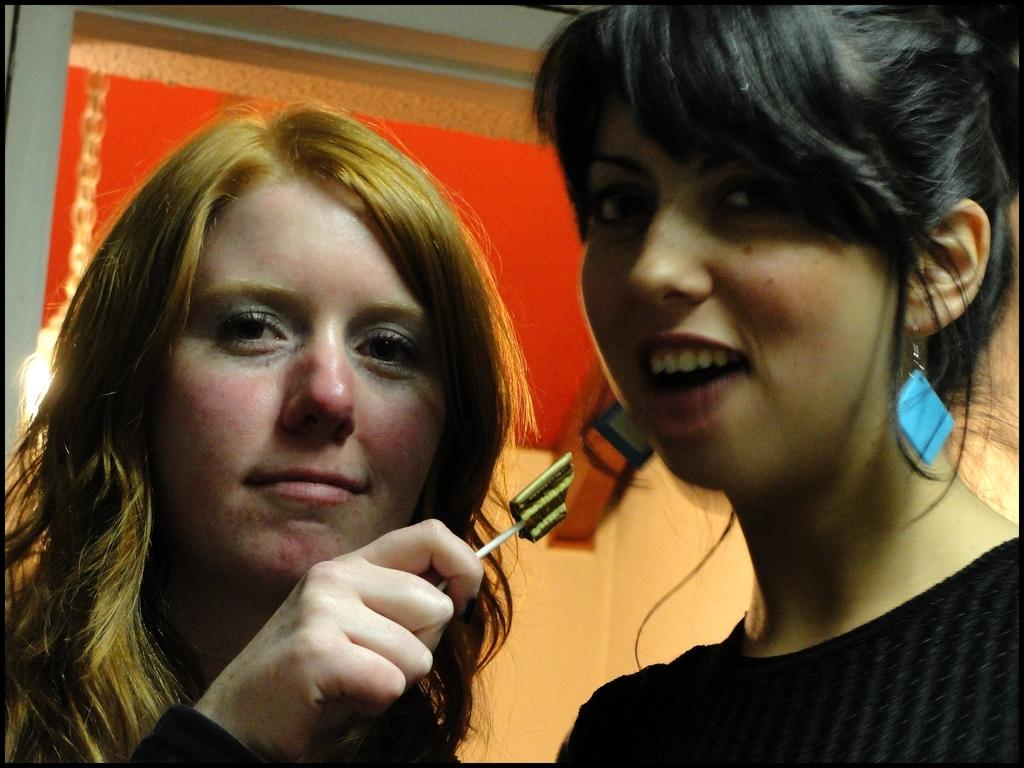How many people are in the image? There are two women in the image. What are the women doing in the image? The women are posing for a picture. Can you describe the woman on the left side of the image? The woman on the left side is holding an object in her hand. What can be seen in the background of the image? There is a wall in the background of the image. What is the aftermath of the women's dad's birthday party in the image? There is no mention of a dad or a birthday party in the image, so it is not possible to discuss the aftermath. 